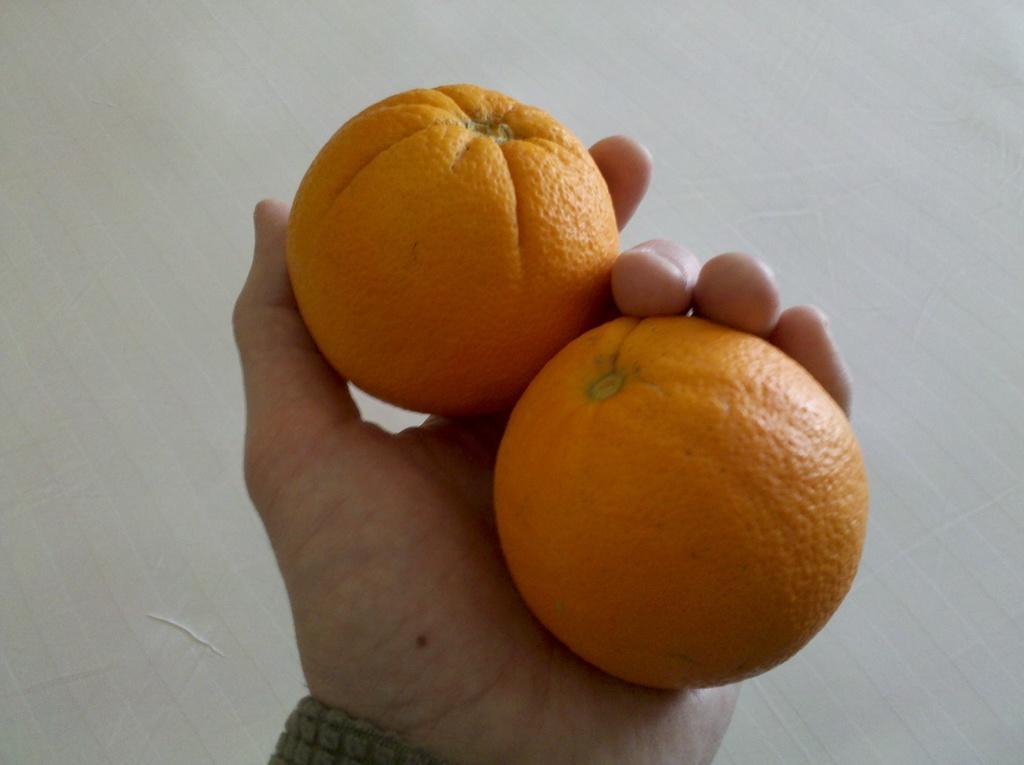How would you summarize this image in a sentence or two? There is one human hand is holding two oranges as we can see in the middle of this image, and the background is in white color. 